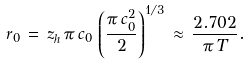<formula> <loc_0><loc_0><loc_500><loc_500>r _ { 0 } \, = \, z _ { h } \, \pi \, c _ { 0 } \, \left ( \frac { \pi \, c _ { 0 } ^ { 2 } } { 2 } \right ) ^ { 1 / 3 } \, \approx \, \frac { 2 . 7 0 2 } { \pi \, T } .</formula> 